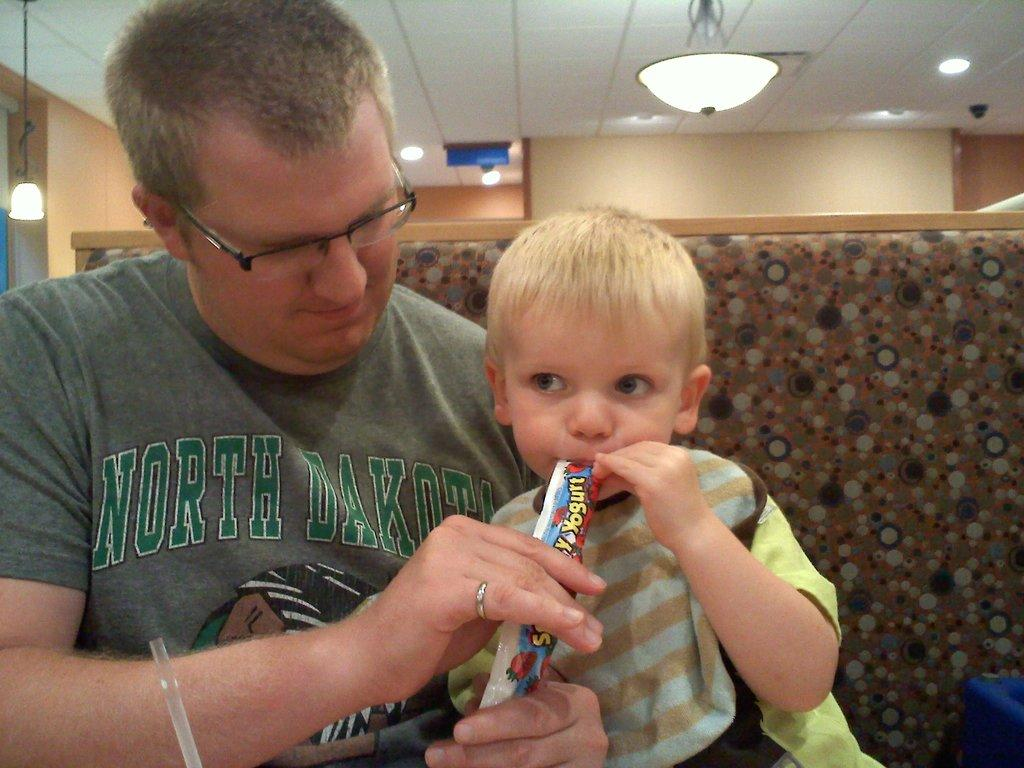What is the man in the image doing? The man is sitting and feeding the baby. Can you describe the baby in the image? The man is holding a baby. What is the background of the image like? There is a wall in the background of the image. What can be seen at the top of the image? Lights are visible at the top of the image. What type of polish is the man applying to the baby's nails in the image? There is no polish or nail care activity depicted in the image. What crime is the man committing in the image? There is no crime being committed in the image; the man is feeding the baby. 